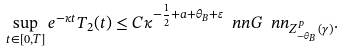<formula> <loc_0><loc_0><loc_500><loc_500>\sup _ { t \in [ 0 , T ] } e ^ { - \kappa t } T _ { 2 } ( t ) \leq C \kappa ^ { - \frac { 1 } { 2 } + a + \theta _ { B } + \varepsilon } \ n n G \ n n _ { Z ^ { p } _ { - \theta _ { B } } ( \gamma ) } .</formula> 